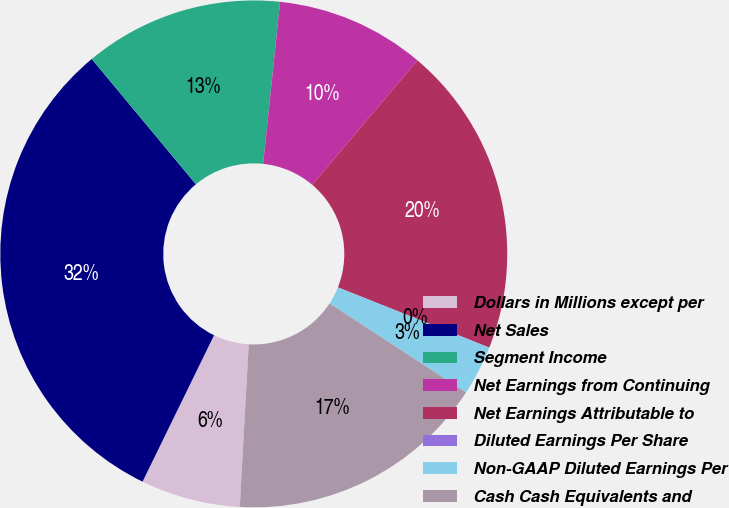Convert chart to OTSL. <chart><loc_0><loc_0><loc_500><loc_500><pie_chart><fcel>Dollars in Millions except per<fcel>Net Sales<fcel>Segment Income<fcel>Net Earnings from Continuing<fcel>Net Earnings Attributable to<fcel>Diluted Earnings Per Share<fcel>Non-GAAP Diluted Earnings Per<fcel>Cash Cash Equivalents and<nl><fcel>6.35%<fcel>31.73%<fcel>12.69%<fcel>9.52%<fcel>19.85%<fcel>0.0%<fcel>3.18%<fcel>16.67%<nl></chart> 